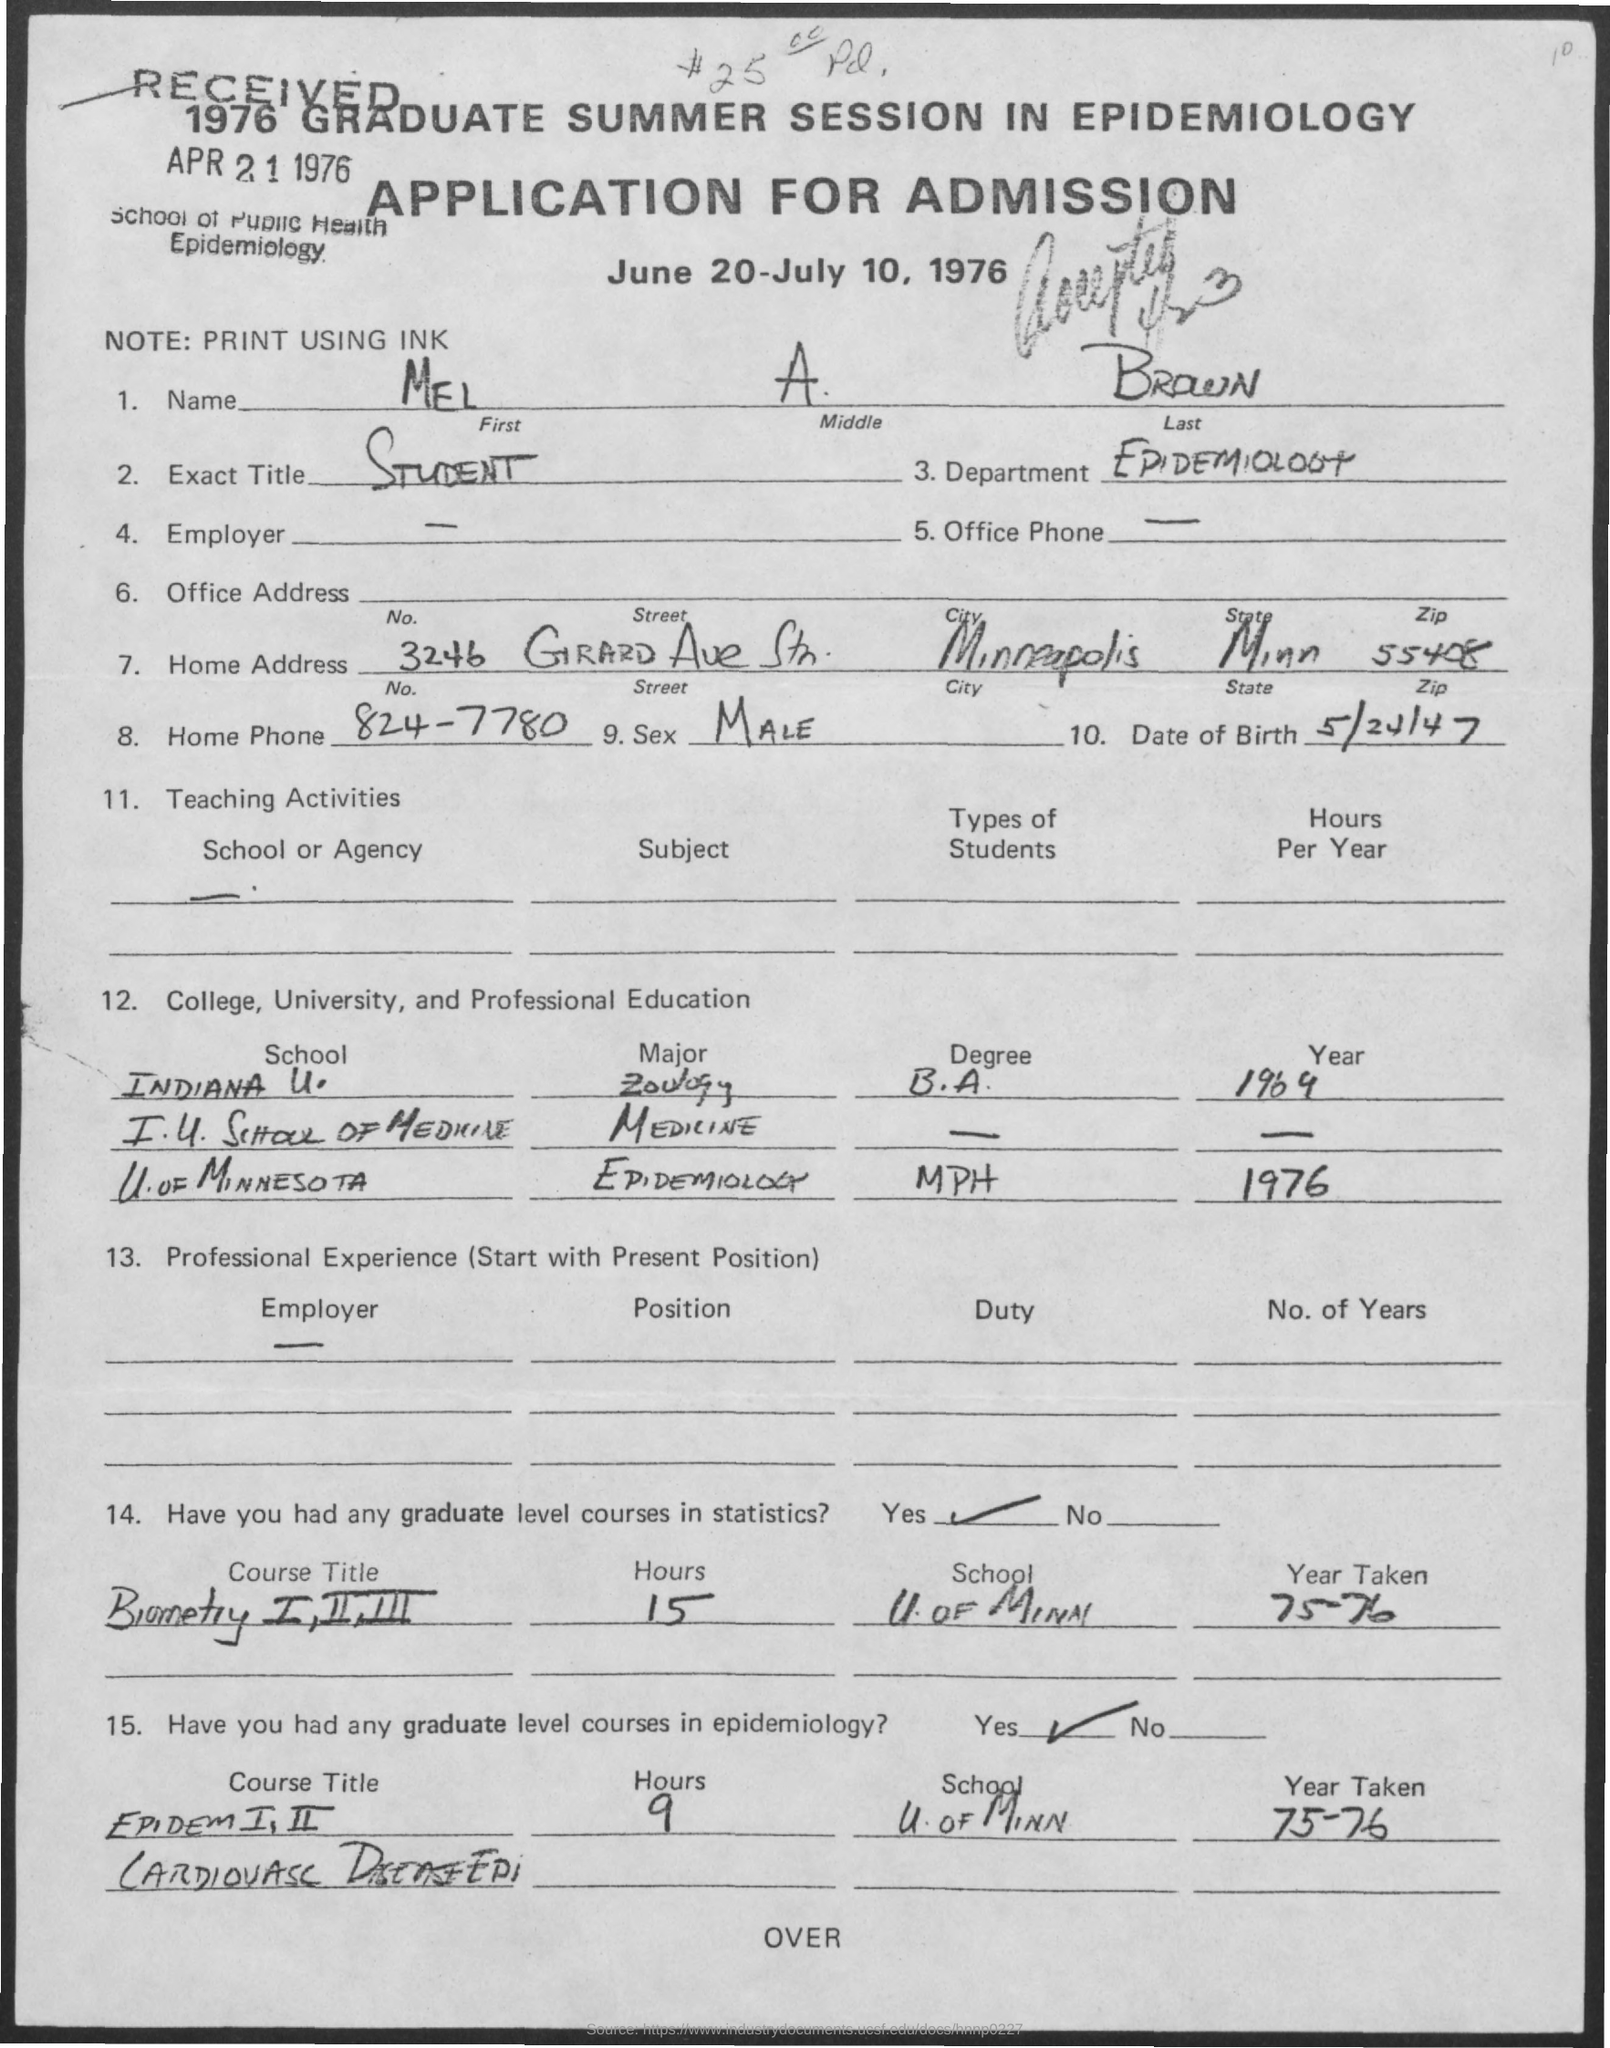When was the application received?
Your response must be concise. 1976. What is the name given?
Provide a succinct answer. MEL A BROWN. What is the exact title given?
Keep it short and to the point. STUDENT. Which department is Mel from?
Make the answer very short. EPIDEMIOLOGY. What is Mel's date of birth?
Make the answer very short. 5/24/47. In which year did Mel major in epidemiology from U. OF MINNESOTA?
Your response must be concise. 1976. 